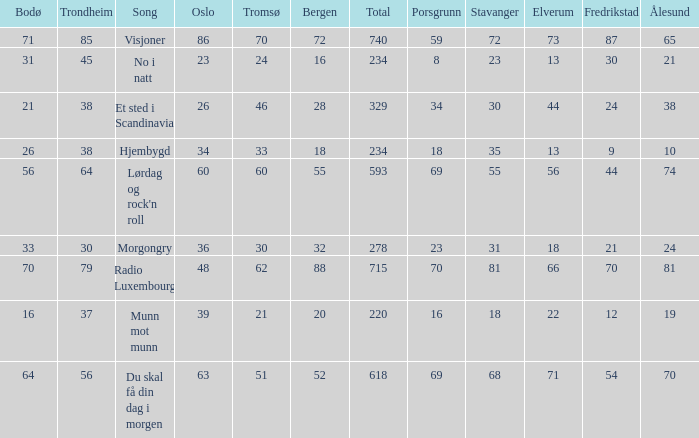Give me the full table as a dictionary. {'header': ['Bodø', 'Trondheim', 'Song', 'Oslo', 'Tromsø', 'Bergen', 'Total', 'Porsgrunn', 'Stavanger', 'Elverum', 'Fredrikstad', 'Ålesund'], 'rows': [['71', '85', 'Visjoner', '86', '70', '72', '740', '59', '72', '73', '87', '65'], ['31', '45', 'No i natt', '23', '24', '16', '234', '8', '23', '13', '30', '21'], ['21', '38', 'Et sted i Scandinavia', '26', '46', '28', '329', '34', '30', '44', '24', '38'], ['26', '38', 'Hjembygd', '34', '33', '18', '234', '18', '35', '13', '9', '10'], ['56', '64', "Lørdag og rock'n roll", '60', '60', '55', '593', '69', '55', '56', '44', '74'], ['33', '30', 'Morgongry', '36', '30', '32', '278', '23', '31', '18', '21', '24'], ['70', '79', 'Radio Luxembourg', '48', '62', '88', '715', '70', '81', '66', '70', '81'], ['16', '37', 'Munn mot munn', '39', '21', '20', '220', '16', '18', '22', '12', '19'], ['64', '56', 'Du skal få din dag i morgen', '63', '51', '52', '618', '69', '68', '71', '54', '70']]} What was the total for radio luxembourg? 715.0. 